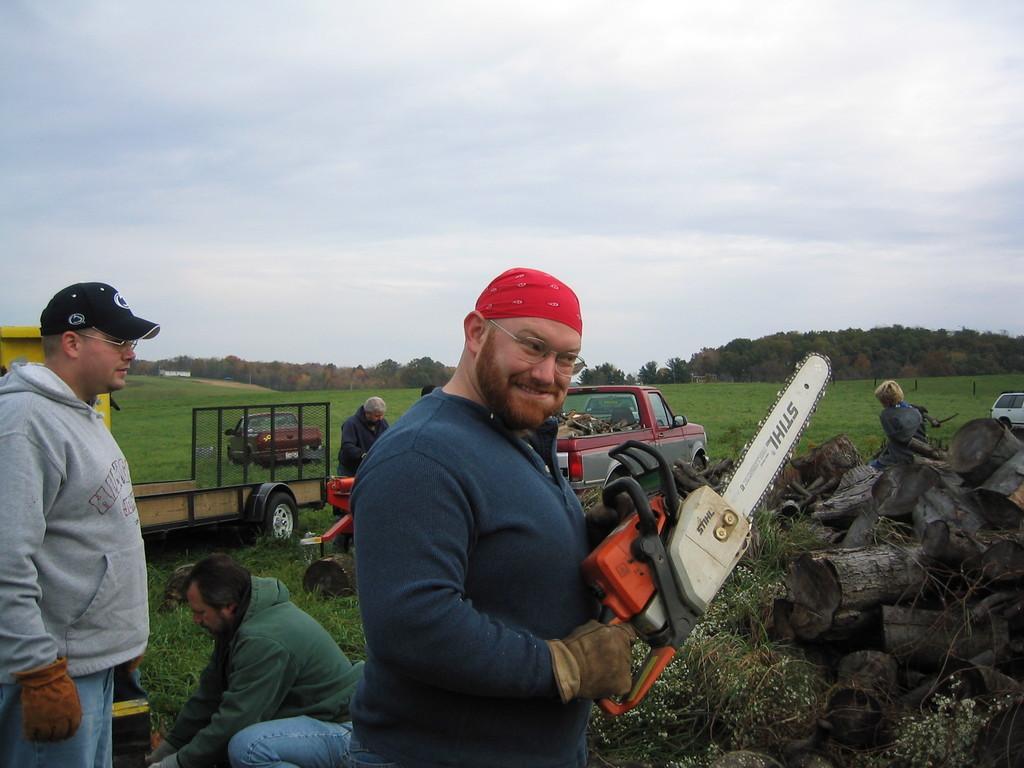In one or two sentences, can you explain what this image depicts? In this image I can see a person is holding an object in hand and four persons on the grass. In the background I can see vehicles, tree trunks, trees, mountains and the sky. This image is taken may be in a farm. 